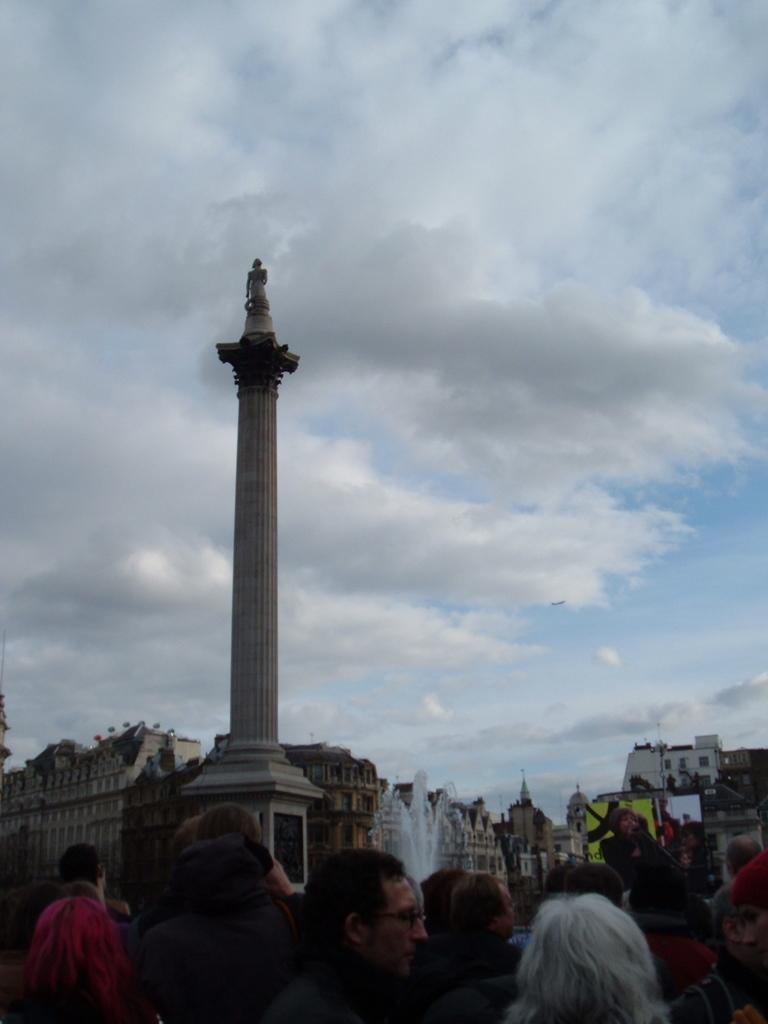What is happening in the image? There are many people standing in a group in the image. What can be seen in the background of the image? There is a fountain, a tower, and buildings visible in the background of the image. What type of flesh can be seen hanging from the tower in the image? There is no flesh present in the image, and the tower does not have any hanging objects. 